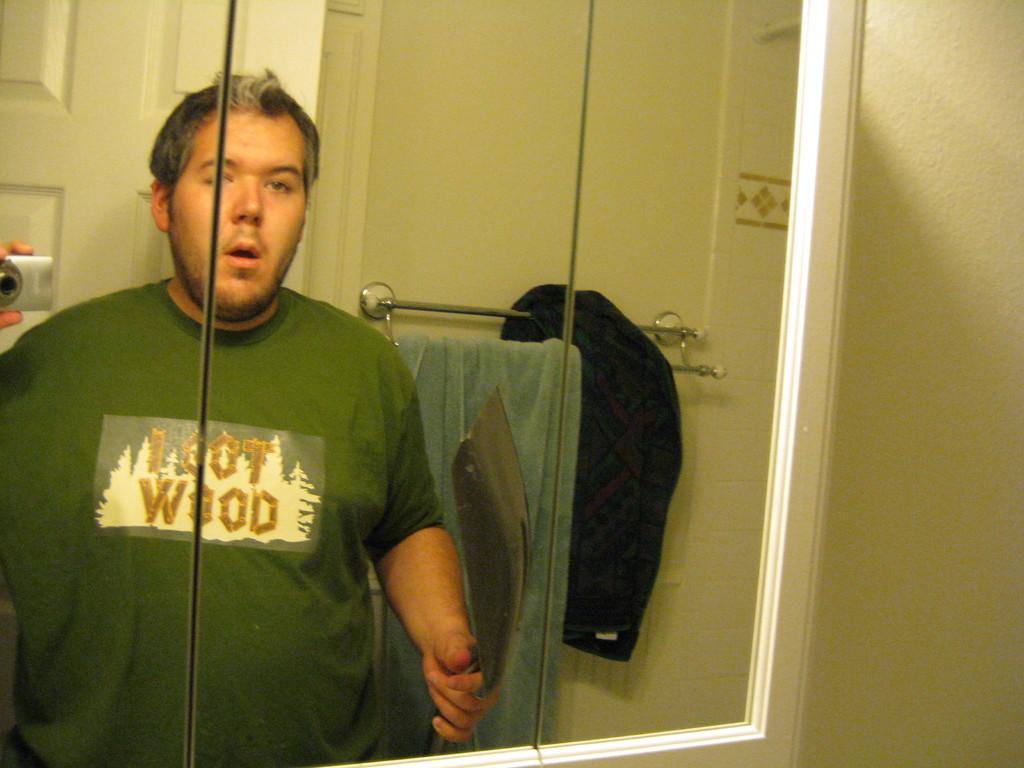<image>
Present a compact description of the photo's key features. Man looking in the mirror with a green shirt that says I Got Wood in gold lettering. 